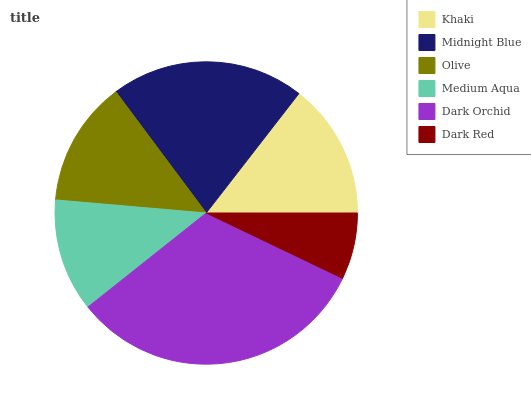Is Dark Red the minimum?
Answer yes or no. Yes. Is Dark Orchid the maximum?
Answer yes or no. Yes. Is Midnight Blue the minimum?
Answer yes or no. No. Is Midnight Blue the maximum?
Answer yes or no. No. Is Midnight Blue greater than Khaki?
Answer yes or no. Yes. Is Khaki less than Midnight Blue?
Answer yes or no. Yes. Is Khaki greater than Midnight Blue?
Answer yes or no. No. Is Midnight Blue less than Khaki?
Answer yes or no. No. Is Khaki the high median?
Answer yes or no. Yes. Is Olive the low median?
Answer yes or no. Yes. Is Dark Orchid the high median?
Answer yes or no. No. Is Medium Aqua the low median?
Answer yes or no. No. 